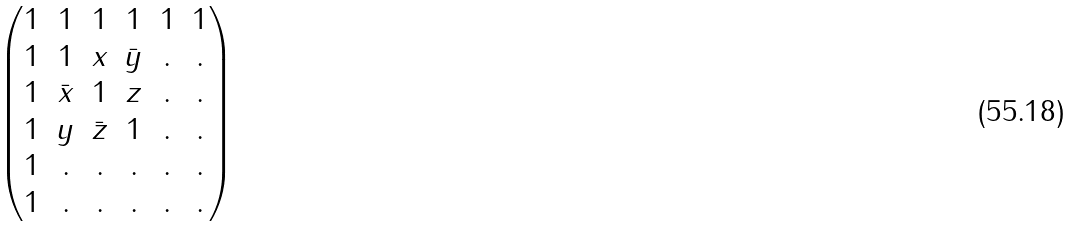Convert formula to latex. <formula><loc_0><loc_0><loc_500><loc_500>\begin{pmatrix} 1 & 1 & 1 & 1 & 1 & 1 \\ 1 & 1 & x & \bar { y } & . & . \\ 1 & \bar { x } & 1 & z & . & . \\ 1 & y & \bar { z } & 1 & . & . \\ 1 & . & . & . & . & . \\ 1 & . & . & . & . & . \end{pmatrix}</formula> 